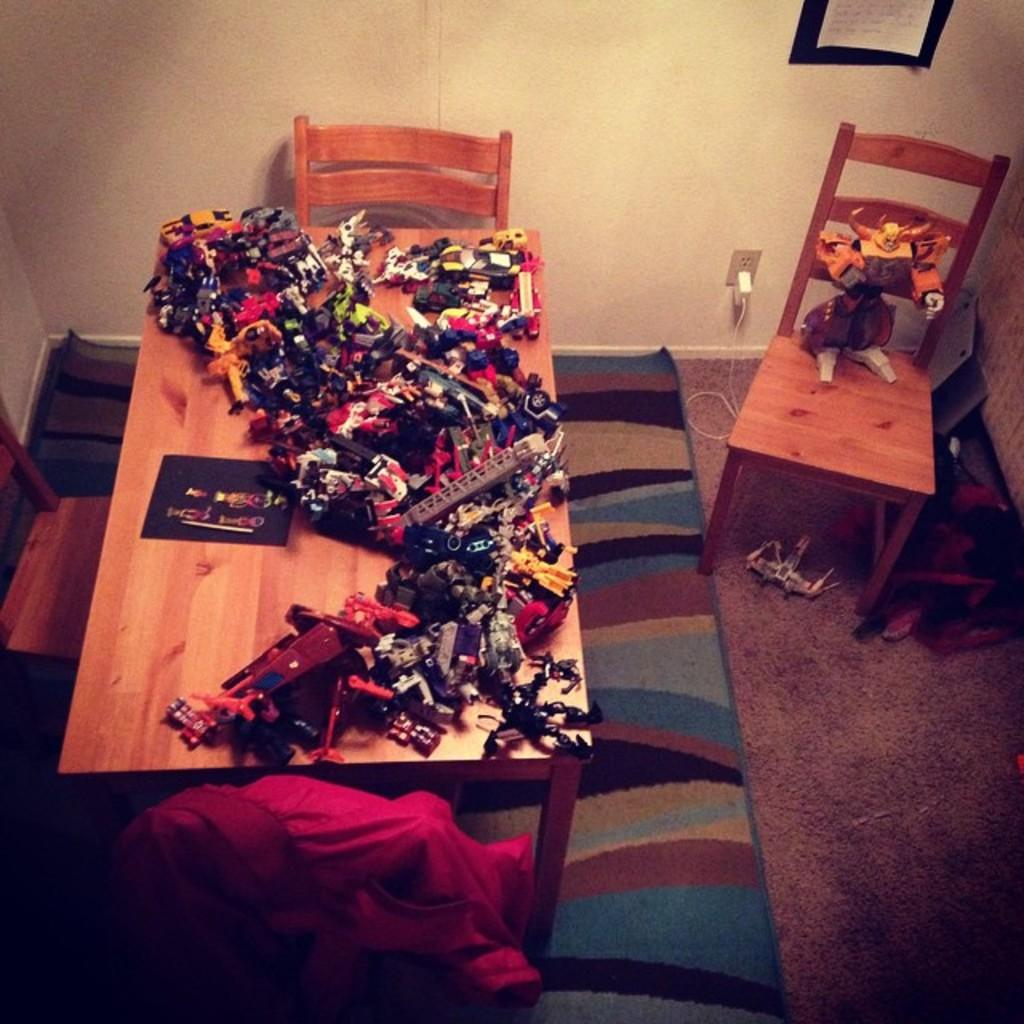What type of furniture is visible in the image? There are chairs in the image. What is on the floor in the image? There is a floor mat in the image. What is the main piece of furniture in the image? There is a table in the image. What is placed on the table? Objects are placed on the table. What can be seen in the background of the image? There is a wall, a socket, and a poster in the background of the image. Where might this image have been taken? The image is likely taken in a room. What type of destruction is happening in the image? There is no destruction present in the image; it shows a room with chairs, a floor mat, a table, and objects on the table. How are the objects being distributed in the image? The objects on the table are not being distributed; they are simply placed on the table. 